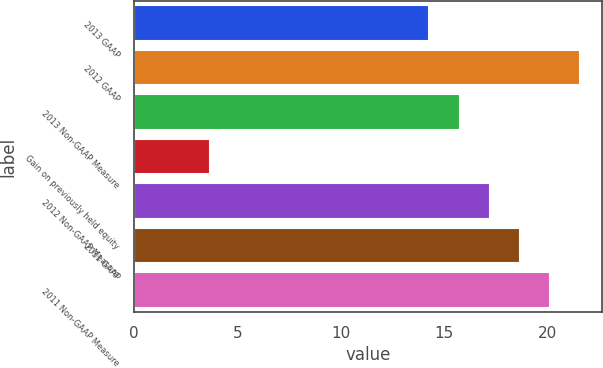Convert chart. <chart><loc_0><loc_0><loc_500><loc_500><bar_chart><fcel>2013 GAAP<fcel>2012 GAAP<fcel>2013 Non-GAAP Measure<fcel>Gain on previously held equity<fcel>2012 Non-GAAP Measure<fcel>2011 GAAP<fcel>2011 Non-GAAP Measure<nl><fcel>14.3<fcel>21.6<fcel>15.76<fcel>3.7<fcel>17.22<fcel>18.68<fcel>20.14<nl></chart> 